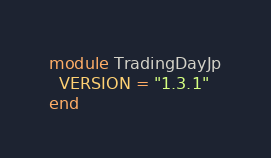Convert code to text. <code><loc_0><loc_0><loc_500><loc_500><_Ruby_>module TradingDayJp
  VERSION = "1.3.1"
end
</code> 